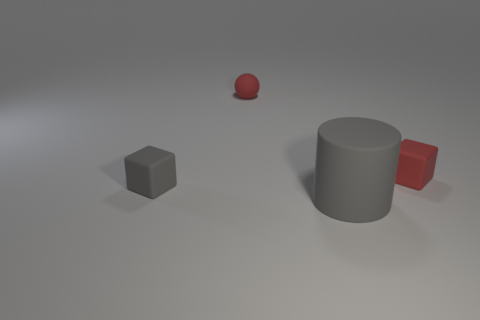Add 3 tiny red objects. How many objects exist? 7 Subtract 0 cyan blocks. How many objects are left? 4 Subtract 1 blocks. How many blocks are left? 1 Subtract all green cubes. Subtract all red spheres. How many cubes are left? 2 Subtract all brown cylinders. How many green balls are left? 0 Subtract all small rubber cubes. Subtract all red matte things. How many objects are left? 0 Add 1 small cubes. How many small cubes are left? 3 Add 1 small gray blocks. How many small gray blocks exist? 2 